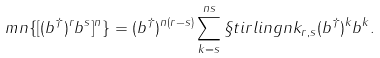Convert formula to latex. <formula><loc_0><loc_0><loc_500><loc_500>\ m n \{ [ ( b ^ { \dag } ) ^ { r } b ^ { s } ] ^ { n } \} = ( b ^ { \dag } ) ^ { n ( r - s ) } \sum _ { k = s } ^ { n s } \S t i r l i n g { n } { k } _ { r , s } ( b ^ { \dag } ) ^ { k } b ^ { k } .</formula> 